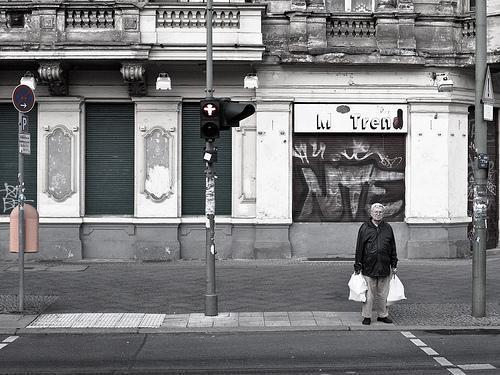How many people are in the photo?
Give a very brief answer. 1. 